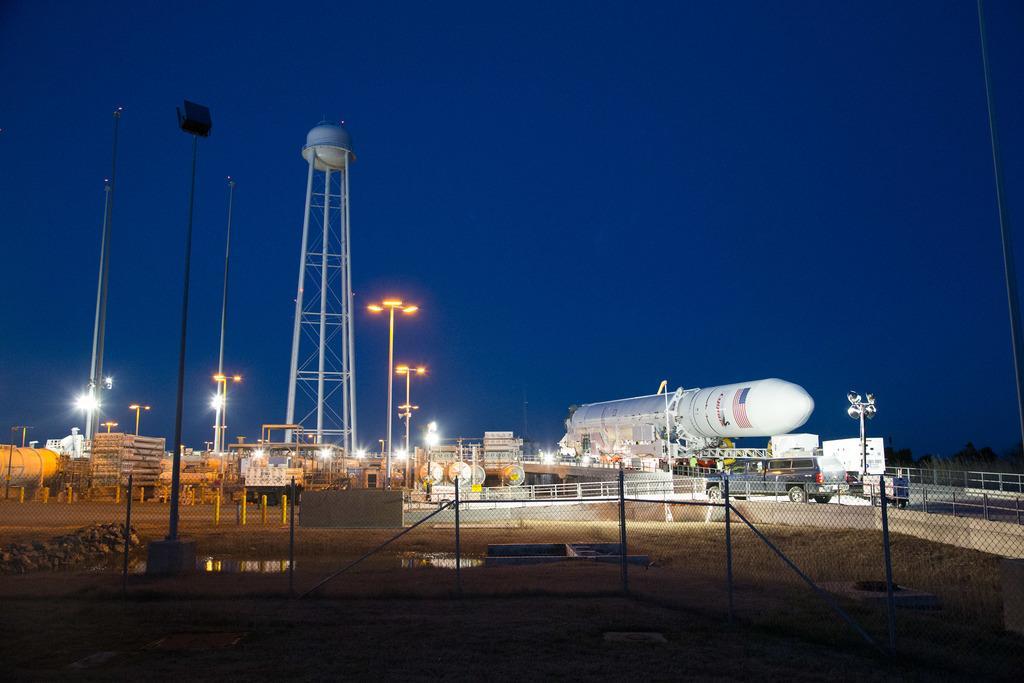Please provide a concise description of this image. In this picture there is a rocket on the right side of the image and there are poles on the left side of the image and there is a net boundary at the bottom side of the image. 